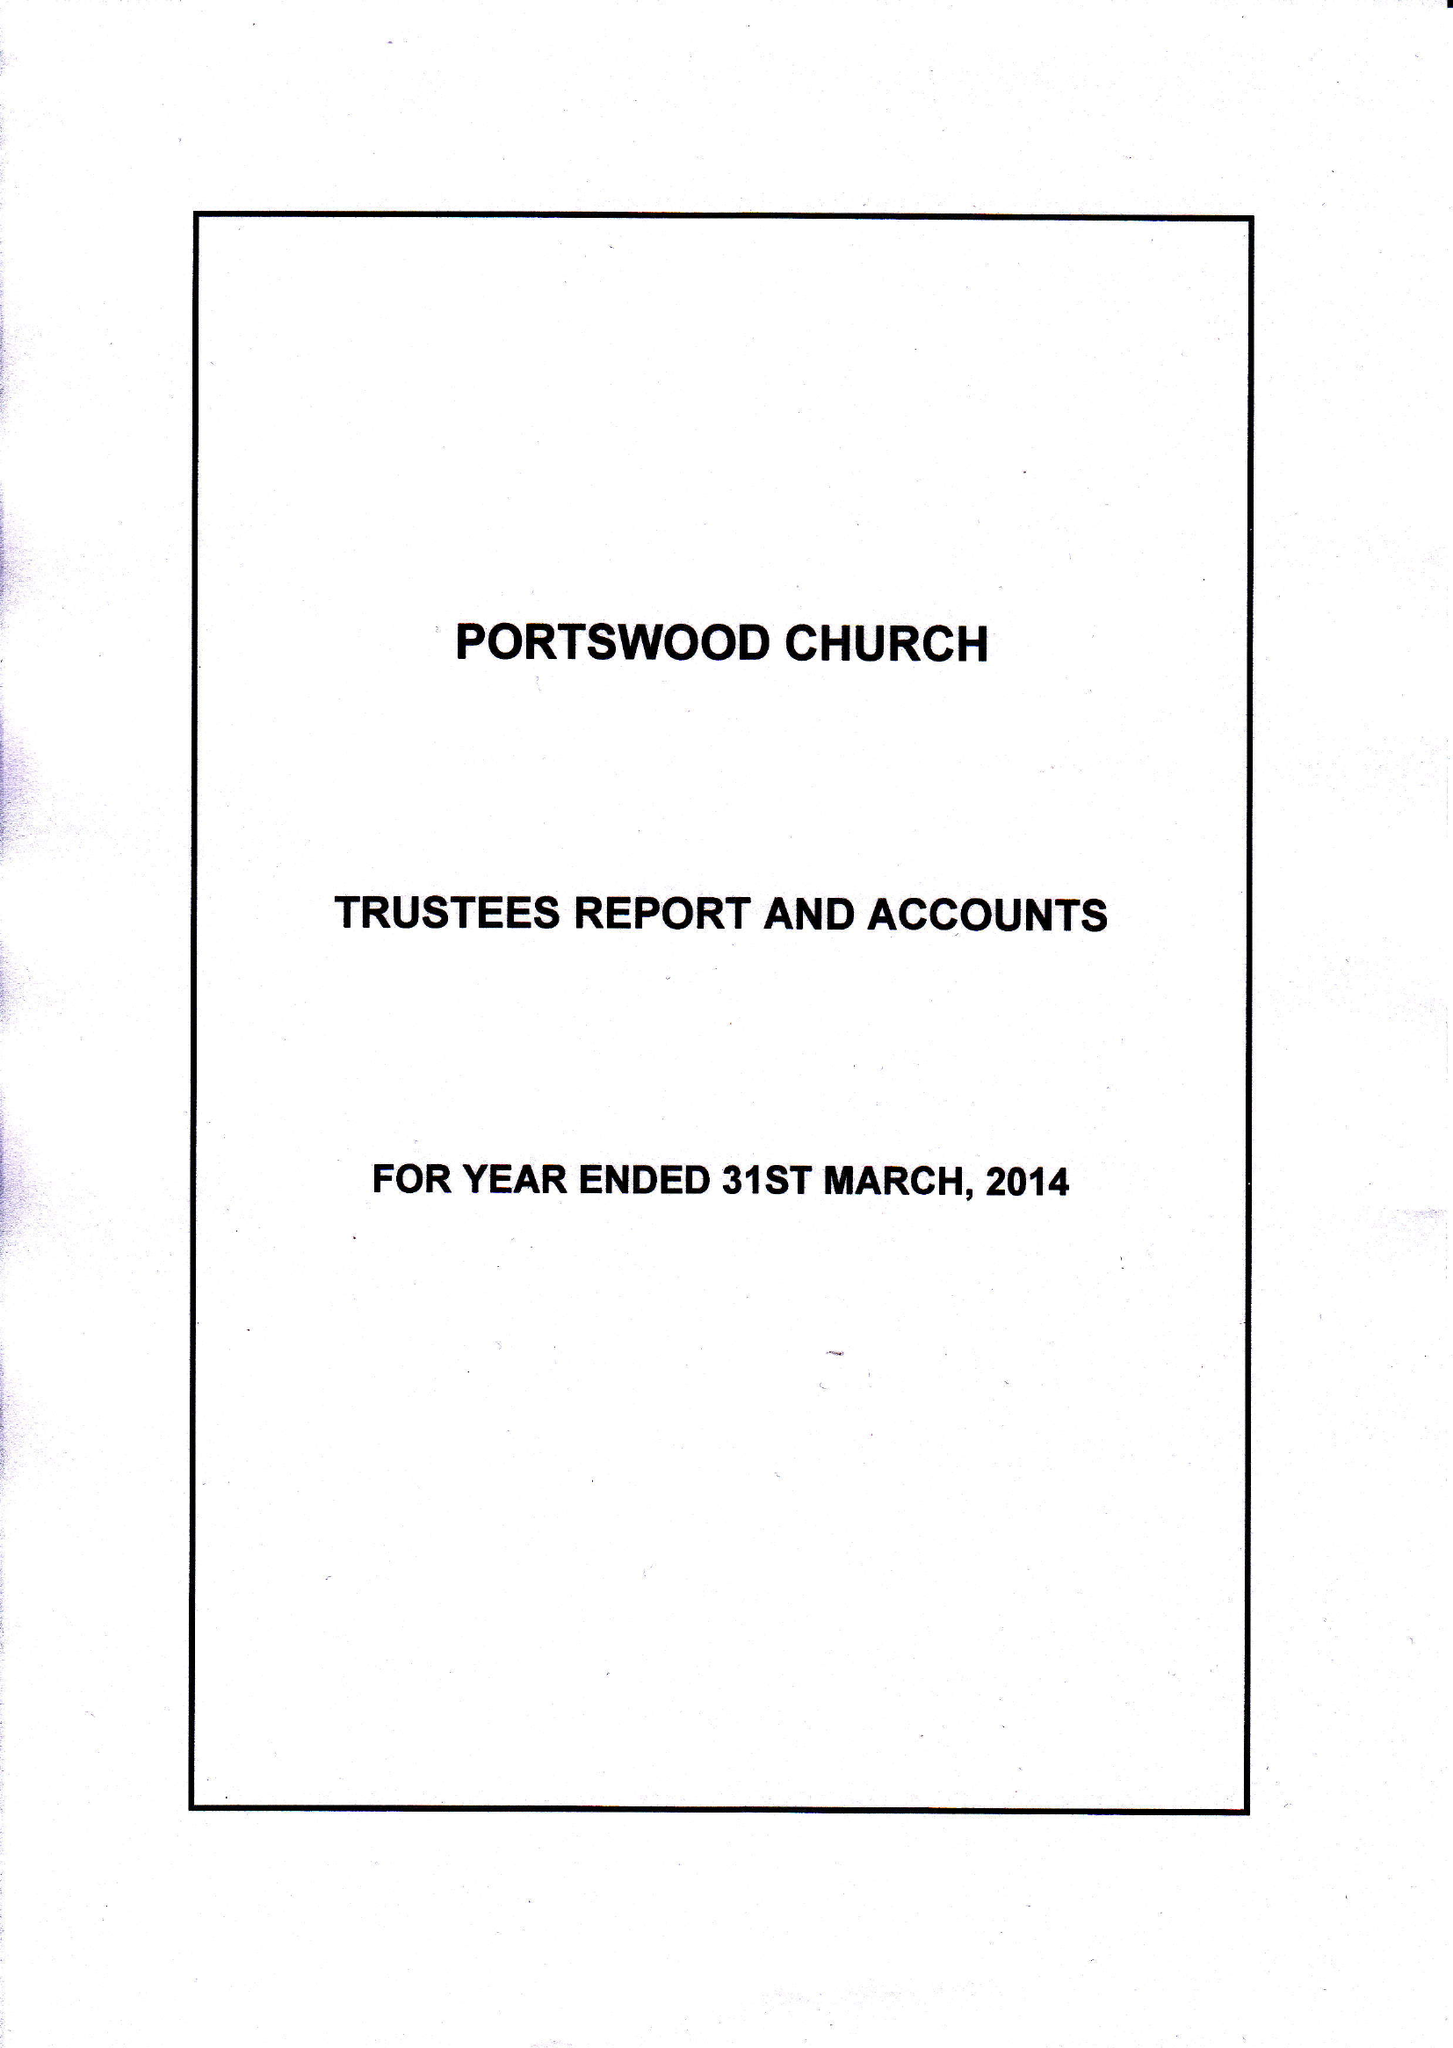What is the value for the address__post_town?
Answer the question using a single word or phrase. SOUTHAMPTON 